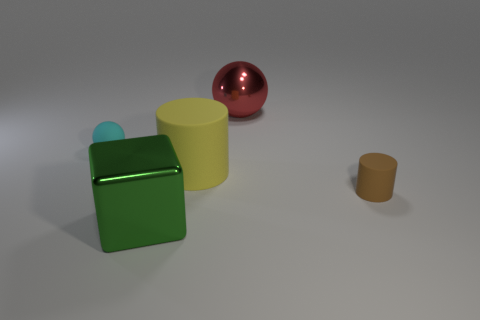What number of other metallic objects are the same shape as the red object?
Your answer should be very brief. 0. What number of small gray metal blocks are there?
Your answer should be very brief. 0. Do the metal thing that is behind the small cyan rubber object and the cyan object have the same shape?
Your answer should be compact. Yes. There is a cylinder that is the same size as the red object; what is its material?
Your response must be concise. Rubber. Is there a thing that has the same material as the tiny cyan sphere?
Give a very brief answer. Yes. There is a red metal thing; is it the same shape as the tiny matte object that is on the left side of the big yellow cylinder?
Provide a succinct answer. Yes. How many objects are behind the metallic cube and on the left side of the small brown object?
Your answer should be compact. 3. Are the cube and the big cylinder that is behind the green object made of the same material?
Offer a very short reply. No. Are there an equal number of large green shiny blocks that are on the left side of the tiny cyan rubber ball and cylinders?
Keep it short and to the point. No. There is a small matte ball that is to the left of the tiny brown thing; what color is it?
Offer a terse response. Cyan. 